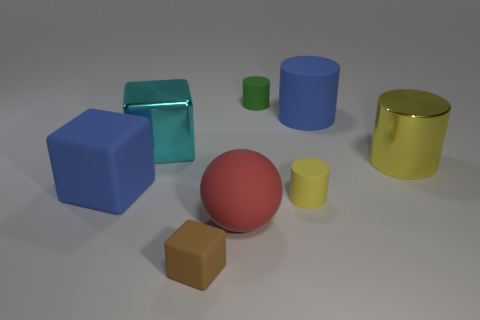How many yellow cylinders must be subtracted to get 1 yellow cylinders? 1 Add 1 large yellow things. How many objects exist? 9 Subtract all matte cylinders. How many cylinders are left? 1 Subtract all cyan cubes. How many cubes are left? 2 Subtract 3 cylinders. How many cylinders are left? 1 Subtract all brown cubes. Subtract all red balls. How many cubes are left? 2 Subtract all brown cylinders. How many brown cubes are left? 1 Subtract all matte things. Subtract all big red rubber spheres. How many objects are left? 1 Add 6 yellow metallic things. How many yellow metallic things are left? 7 Add 1 big cylinders. How many big cylinders exist? 3 